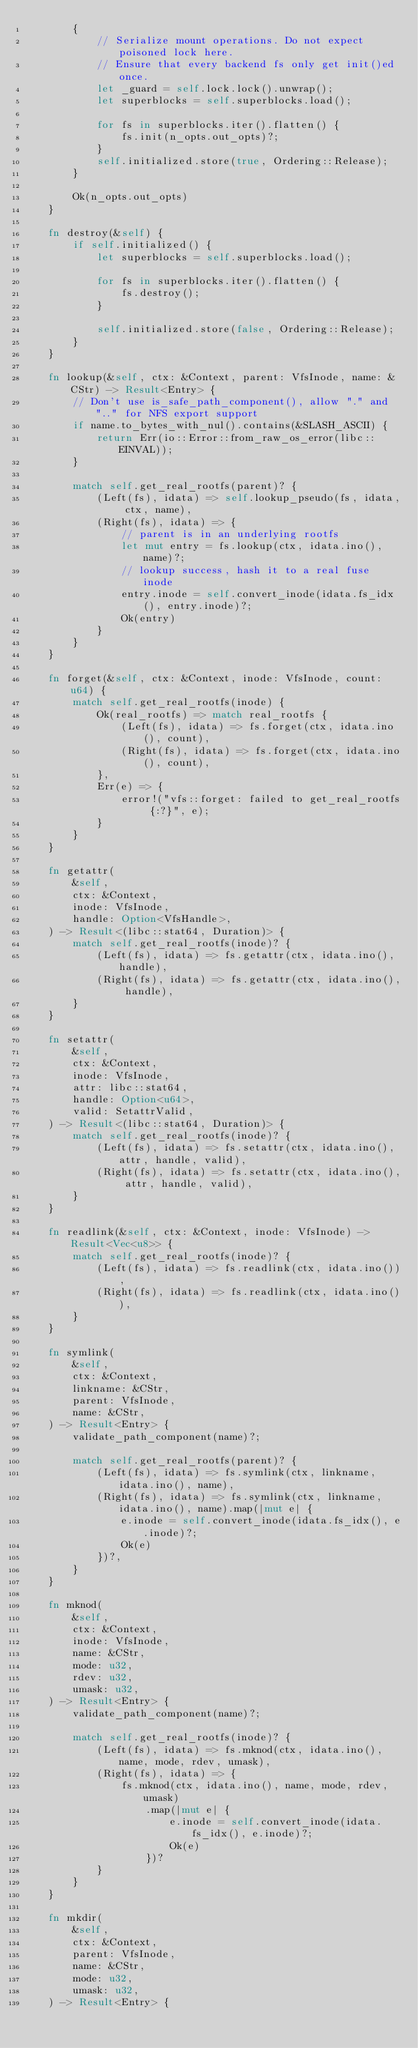Convert code to text. <code><loc_0><loc_0><loc_500><loc_500><_Rust_>        {
            // Serialize mount operations. Do not expect poisoned lock here.
            // Ensure that every backend fs only get init()ed once.
            let _guard = self.lock.lock().unwrap();
            let superblocks = self.superblocks.load();

            for fs in superblocks.iter().flatten() {
                fs.init(n_opts.out_opts)?;
            }
            self.initialized.store(true, Ordering::Release);
        }

        Ok(n_opts.out_opts)
    }

    fn destroy(&self) {
        if self.initialized() {
            let superblocks = self.superblocks.load();

            for fs in superblocks.iter().flatten() {
                fs.destroy();
            }

            self.initialized.store(false, Ordering::Release);
        }
    }

    fn lookup(&self, ctx: &Context, parent: VfsInode, name: &CStr) -> Result<Entry> {
        // Don't use is_safe_path_component(), allow "." and ".." for NFS export support
        if name.to_bytes_with_nul().contains(&SLASH_ASCII) {
            return Err(io::Error::from_raw_os_error(libc::EINVAL));
        }

        match self.get_real_rootfs(parent)? {
            (Left(fs), idata) => self.lookup_pseudo(fs, idata, ctx, name),
            (Right(fs), idata) => {
                // parent is in an underlying rootfs
                let mut entry = fs.lookup(ctx, idata.ino(), name)?;
                // lookup success, hash it to a real fuse inode
                entry.inode = self.convert_inode(idata.fs_idx(), entry.inode)?;
                Ok(entry)
            }
        }
    }

    fn forget(&self, ctx: &Context, inode: VfsInode, count: u64) {
        match self.get_real_rootfs(inode) {
            Ok(real_rootfs) => match real_rootfs {
                (Left(fs), idata) => fs.forget(ctx, idata.ino(), count),
                (Right(fs), idata) => fs.forget(ctx, idata.ino(), count),
            },
            Err(e) => {
                error!("vfs::forget: failed to get_real_rootfs {:?}", e);
            }
        }
    }

    fn getattr(
        &self,
        ctx: &Context,
        inode: VfsInode,
        handle: Option<VfsHandle>,
    ) -> Result<(libc::stat64, Duration)> {
        match self.get_real_rootfs(inode)? {
            (Left(fs), idata) => fs.getattr(ctx, idata.ino(), handle),
            (Right(fs), idata) => fs.getattr(ctx, idata.ino(), handle),
        }
    }

    fn setattr(
        &self,
        ctx: &Context,
        inode: VfsInode,
        attr: libc::stat64,
        handle: Option<u64>,
        valid: SetattrValid,
    ) -> Result<(libc::stat64, Duration)> {
        match self.get_real_rootfs(inode)? {
            (Left(fs), idata) => fs.setattr(ctx, idata.ino(), attr, handle, valid),
            (Right(fs), idata) => fs.setattr(ctx, idata.ino(), attr, handle, valid),
        }
    }

    fn readlink(&self, ctx: &Context, inode: VfsInode) -> Result<Vec<u8>> {
        match self.get_real_rootfs(inode)? {
            (Left(fs), idata) => fs.readlink(ctx, idata.ino()),
            (Right(fs), idata) => fs.readlink(ctx, idata.ino()),
        }
    }

    fn symlink(
        &self,
        ctx: &Context,
        linkname: &CStr,
        parent: VfsInode,
        name: &CStr,
    ) -> Result<Entry> {
        validate_path_component(name)?;

        match self.get_real_rootfs(parent)? {
            (Left(fs), idata) => fs.symlink(ctx, linkname, idata.ino(), name),
            (Right(fs), idata) => fs.symlink(ctx, linkname, idata.ino(), name).map(|mut e| {
                e.inode = self.convert_inode(idata.fs_idx(), e.inode)?;
                Ok(e)
            })?,
        }
    }

    fn mknod(
        &self,
        ctx: &Context,
        inode: VfsInode,
        name: &CStr,
        mode: u32,
        rdev: u32,
        umask: u32,
    ) -> Result<Entry> {
        validate_path_component(name)?;

        match self.get_real_rootfs(inode)? {
            (Left(fs), idata) => fs.mknod(ctx, idata.ino(), name, mode, rdev, umask),
            (Right(fs), idata) => {
                fs.mknod(ctx, idata.ino(), name, mode, rdev, umask)
                    .map(|mut e| {
                        e.inode = self.convert_inode(idata.fs_idx(), e.inode)?;
                        Ok(e)
                    })?
            }
        }
    }

    fn mkdir(
        &self,
        ctx: &Context,
        parent: VfsInode,
        name: &CStr,
        mode: u32,
        umask: u32,
    ) -> Result<Entry> {</code> 